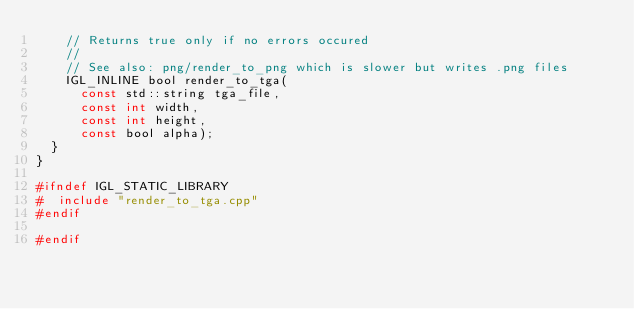Convert code to text. <code><loc_0><loc_0><loc_500><loc_500><_C_>    // Returns true only if no errors occured
    //
    // See also: png/render_to_png which is slower but writes .png files
    IGL_INLINE bool render_to_tga(
      const std::string tga_file,
      const int width,
      const int height,
      const bool alpha);
  }
}

#ifndef IGL_STATIC_LIBRARY
#  include "render_to_tga.cpp"
#endif

#endif
</code> 